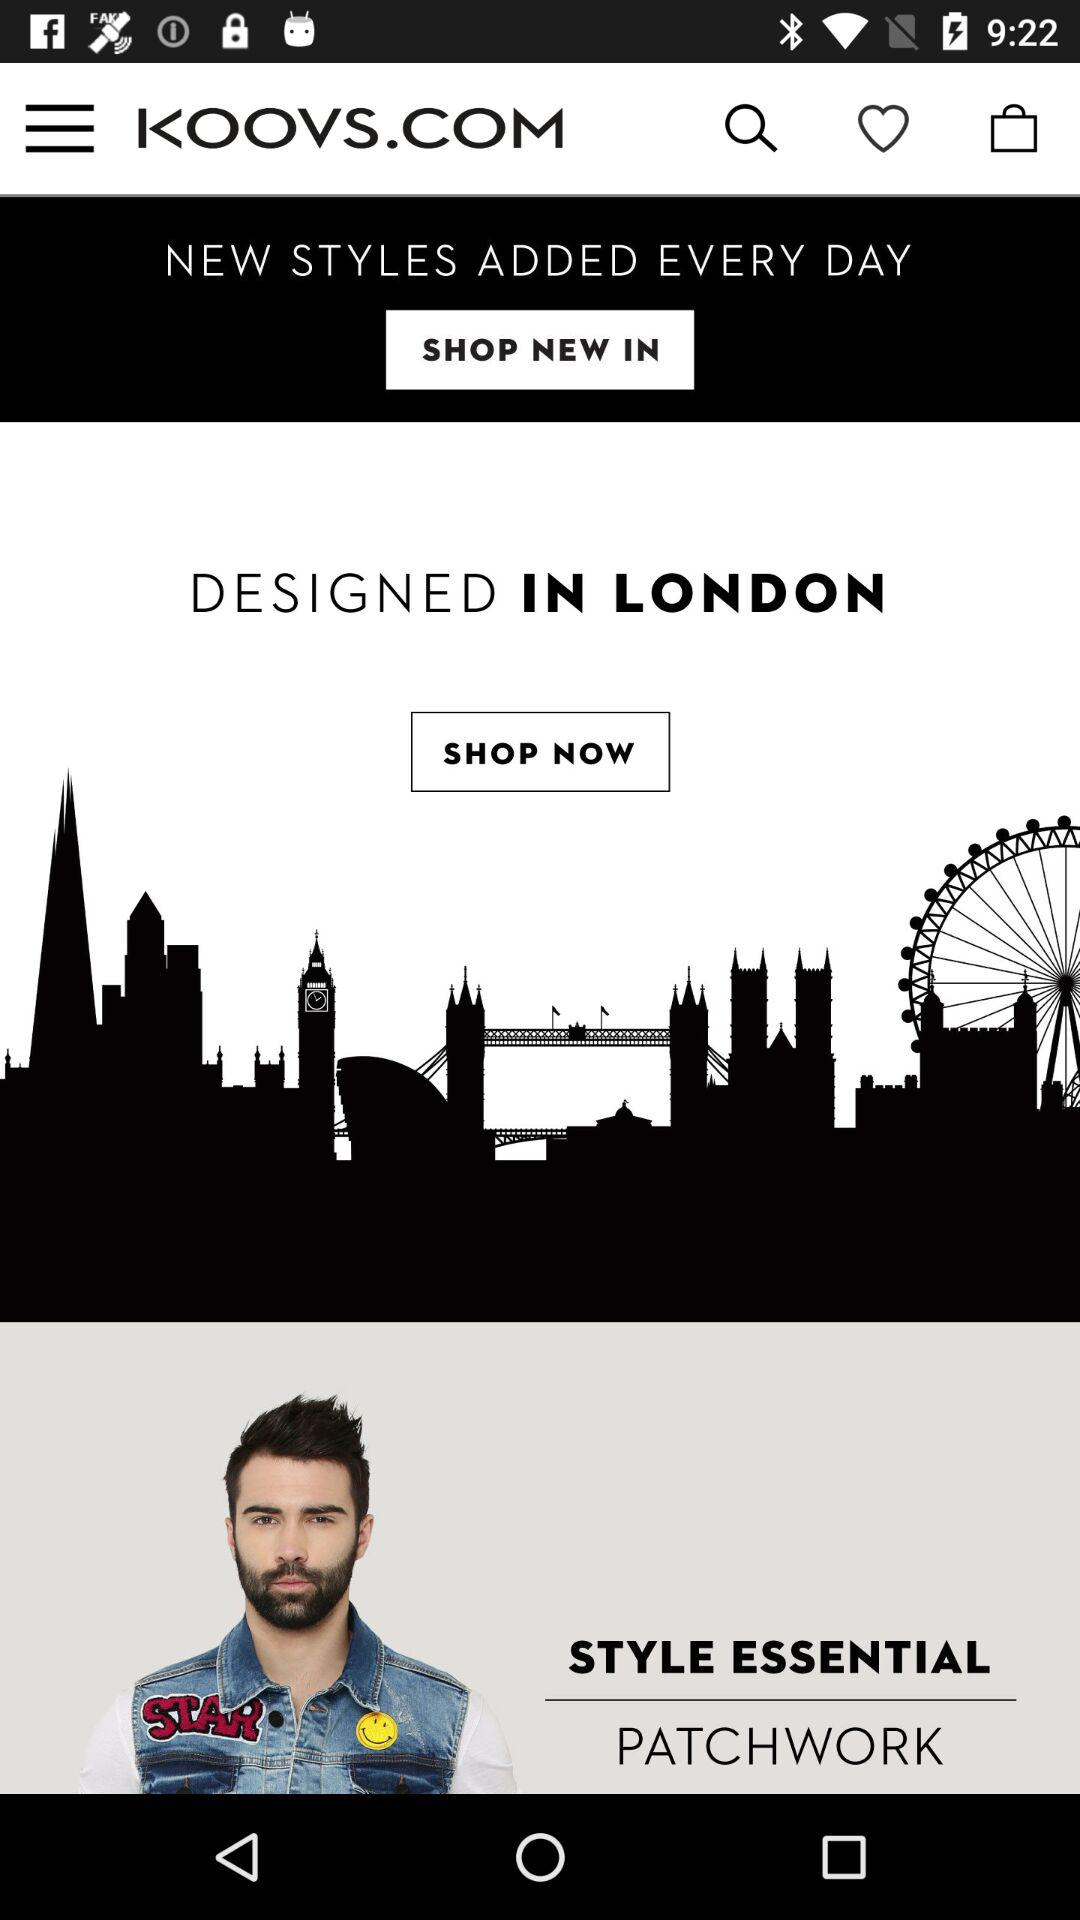Where is it designed? It is designed in London. 